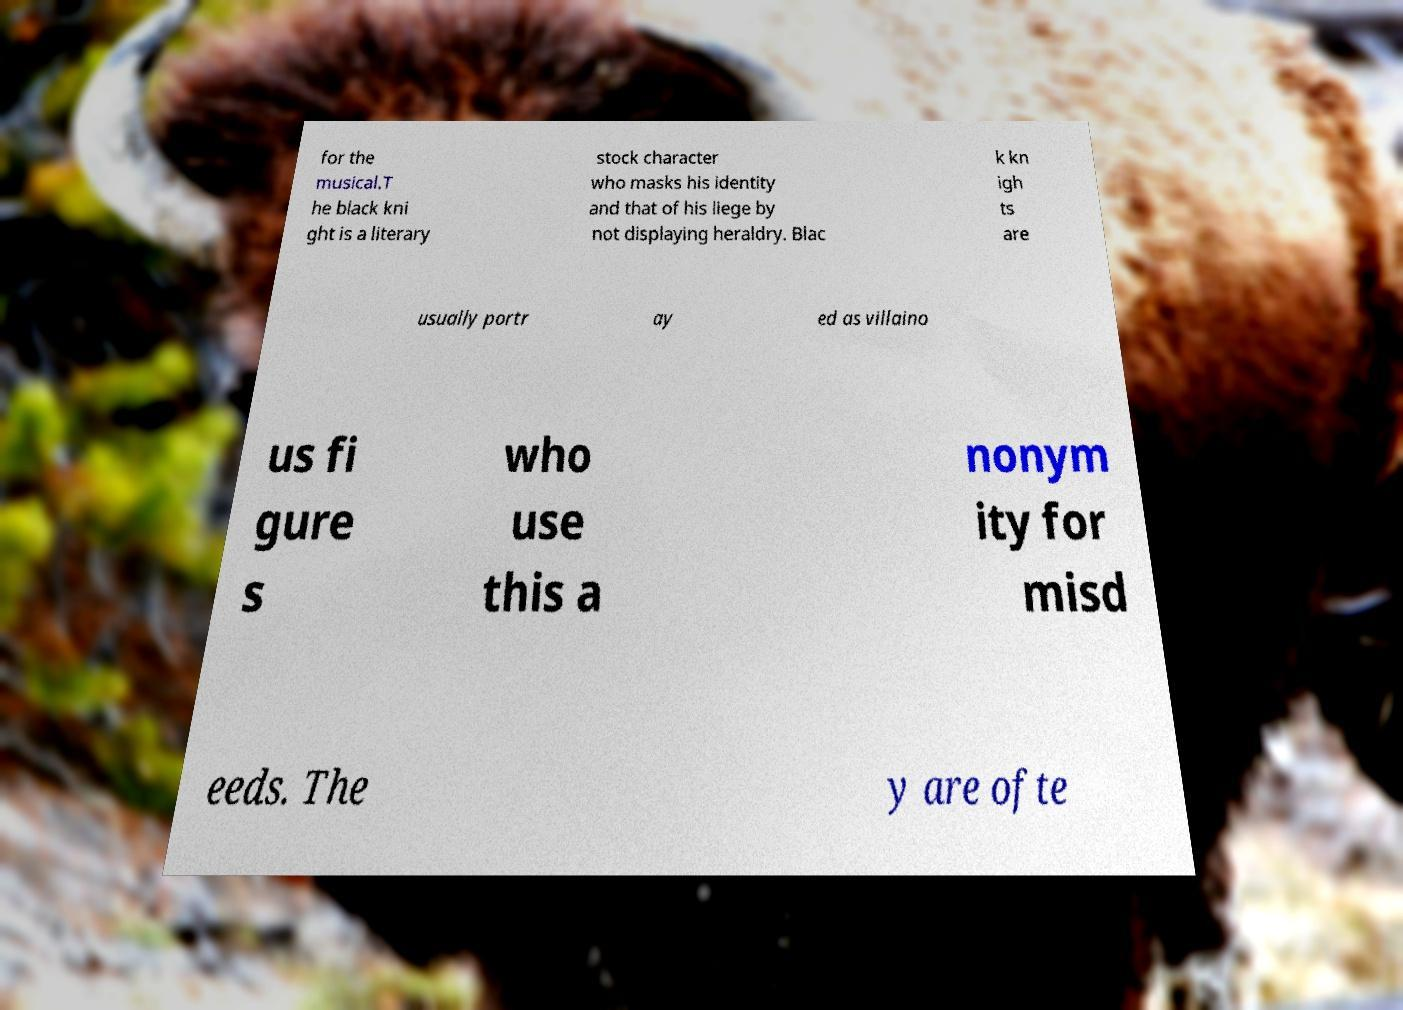Please identify and transcribe the text found in this image. for the musical.T he black kni ght is a literary stock character who masks his identity and that of his liege by not displaying heraldry. Blac k kn igh ts are usually portr ay ed as villaino us fi gure s who use this a nonym ity for misd eeds. The y are ofte 